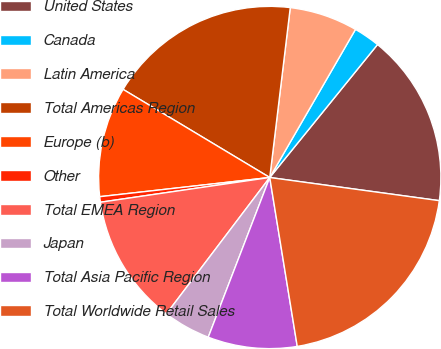Convert chart to OTSL. <chart><loc_0><loc_0><loc_500><loc_500><pie_chart><fcel>United States<fcel>Canada<fcel>Latin America<fcel>Total Americas Region<fcel>Europe (b)<fcel>Other<fcel>Total EMEA Region<fcel>Japan<fcel>Total Asia Pacific Region<fcel>Total Worldwide Retail Sales<nl><fcel>16.32%<fcel>2.49%<fcel>6.44%<fcel>18.3%<fcel>10.4%<fcel>0.52%<fcel>12.37%<fcel>4.47%<fcel>8.42%<fcel>20.27%<nl></chart> 